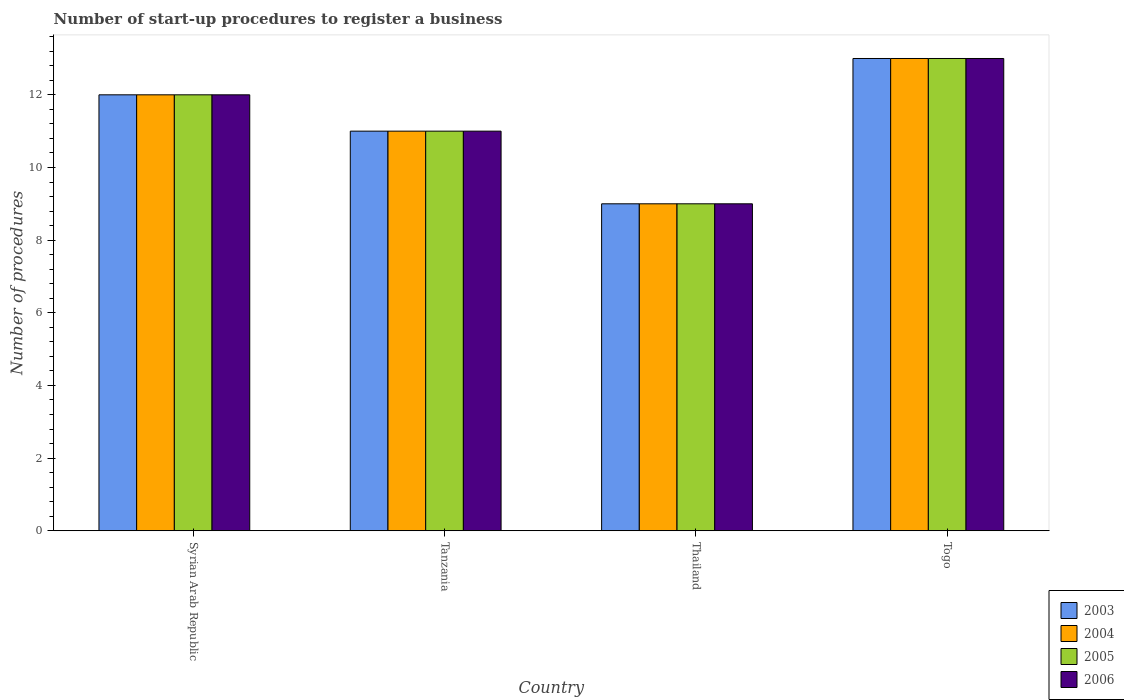How many different coloured bars are there?
Keep it short and to the point. 4. How many groups of bars are there?
Give a very brief answer. 4. Are the number of bars per tick equal to the number of legend labels?
Offer a very short reply. Yes. Are the number of bars on each tick of the X-axis equal?
Provide a short and direct response. Yes. How many bars are there on the 2nd tick from the right?
Give a very brief answer. 4. What is the label of the 3rd group of bars from the left?
Ensure brevity in your answer.  Thailand. Across all countries, what is the maximum number of procedures required to register a business in 2005?
Ensure brevity in your answer.  13. Across all countries, what is the minimum number of procedures required to register a business in 2006?
Offer a terse response. 9. In which country was the number of procedures required to register a business in 2006 maximum?
Give a very brief answer. Togo. In which country was the number of procedures required to register a business in 2006 minimum?
Your answer should be compact. Thailand. What is the average number of procedures required to register a business in 2006 per country?
Your answer should be compact. 11.25. What is the difference between the number of procedures required to register a business of/in 2006 and number of procedures required to register a business of/in 2003 in Tanzania?
Your answer should be compact. 0. In how many countries, is the number of procedures required to register a business in 2006 greater than 12.8?
Offer a very short reply. 1. What is the ratio of the number of procedures required to register a business in 2003 in Syrian Arab Republic to that in Thailand?
Provide a succinct answer. 1.33. Is the number of procedures required to register a business in 2006 in Tanzania less than that in Togo?
Provide a short and direct response. Yes. Is it the case that in every country, the sum of the number of procedures required to register a business in 2006 and number of procedures required to register a business in 2005 is greater than the sum of number of procedures required to register a business in 2004 and number of procedures required to register a business in 2003?
Offer a terse response. No. What does the 2nd bar from the left in Syrian Arab Republic represents?
Give a very brief answer. 2004. What does the 3rd bar from the right in Syrian Arab Republic represents?
Ensure brevity in your answer.  2004. How many bars are there?
Your response must be concise. 16. What is the difference between two consecutive major ticks on the Y-axis?
Offer a terse response. 2. Does the graph contain grids?
Offer a very short reply. No. How are the legend labels stacked?
Provide a succinct answer. Vertical. What is the title of the graph?
Make the answer very short. Number of start-up procedures to register a business. Does "1998" appear as one of the legend labels in the graph?
Ensure brevity in your answer.  No. What is the label or title of the X-axis?
Make the answer very short. Country. What is the label or title of the Y-axis?
Offer a terse response. Number of procedures. What is the Number of procedures in 2004 in Syrian Arab Republic?
Provide a short and direct response. 12. What is the Number of procedures in 2006 in Syrian Arab Republic?
Your answer should be compact. 12. What is the Number of procedures in 2003 in Tanzania?
Provide a short and direct response. 11. What is the Number of procedures of 2004 in Tanzania?
Offer a very short reply. 11. What is the Number of procedures in 2005 in Tanzania?
Offer a terse response. 11. What is the Number of procedures of 2006 in Tanzania?
Give a very brief answer. 11. What is the Number of procedures in 2004 in Thailand?
Offer a terse response. 9. What is the Number of procedures in 2006 in Thailand?
Provide a succinct answer. 9. What is the Number of procedures of 2003 in Togo?
Keep it short and to the point. 13. What is the Number of procedures of 2005 in Togo?
Offer a very short reply. 13. What is the Number of procedures of 2006 in Togo?
Your response must be concise. 13. Across all countries, what is the maximum Number of procedures in 2003?
Give a very brief answer. 13. Across all countries, what is the maximum Number of procedures in 2004?
Provide a short and direct response. 13. Across all countries, what is the maximum Number of procedures of 2005?
Offer a very short reply. 13. Across all countries, what is the minimum Number of procedures in 2006?
Keep it short and to the point. 9. What is the total Number of procedures in 2003 in the graph?
Your response must be concise. 45. What is the total Number of procedures of 2005 in the graph?
Your answer should be compact. 45. What is the total Number of procedures of 2006 in the graph?
Offer a very short reply. 45. What is the difference between the Number of procedures in 2004 in Syrian Arab Republic and that in Tanzania?
Provide a succinct answer. 1. What is the difference between the Number of procedures in 2003 in Syrian Arab Republic and that in Thailand?
Ensure brevity in your answer.  3. What is the difference between the Number of procedures in 2004 in Syrian Arab Republic and that in Thailand?
Keep it short and to the point. 3. What is the difference between the Number of procedures in 2005 in Syrian Arab Republic and that in Thailand?
Your answer should be compact. 3. What is the difference between the Number of procedures in 2003 in Syrian Arab Republic and that in Togo?
Your response must be concise. -1. What is the difference between the Number of procedures of 2004 in Syrian Arab Republic and that in Togo?
Ensure brevity in your answer.  -1. What is the difference between the Number of procedures in 2006 in Syrian Arab Republic and that in Togo?
Offer a very short reply. -1. What is the difference between the Number of procedures of 2003 in Tanzania and that in Thailand?
Give a very brief answer. 2. What is the difference between the Number of procedures of 2004 in Tanzania and that in Thailand?
Provide a succinct answer. 2. What is the difference between the Number of procedures of 2006 in Tanzania and that in Togo?
Offer a very short reply. -2. What is the difference between the Number of procedures in 2003 in Thailand and that in Togo?
Your answer should be very brief. -4. What is the difference between the Number of procedures of 2004 in Thailand and that in Togo?
Offer a terse response. -4. What is the difference between the Number of procedures of 2005 in Thailand and that in Togo?
Keep it short and to the point. -4. What is the difference between the Number of procedures of 2006 in Thailand and that in Togo?
Make the answer very short. -4. What is the difference between the Number of procedures of 2003 in Syrian Arab Republic and the Number of procedures of 2004 in Tanzania?
Ensure brevity in your answer.  1. What is the difference between the Number of procedures of 2003 in Syrian Arab Republic and the Number of procedures of 2005 in Tanzania?
Your answer should be very brief. 1. What is the difference between the Number of procedures in 2004 in Syrian Arab Republic and the Number of procedures in 2005 in Tanzania?
Give a very brief answer. 1. What is the difference between the Number of procedures of 2004 in Syrian Arab Republic and the Number of procedures of 2006 in Tanzania?
Keep it short and to the point. 1. What is the difference between the Number of procedures of 2003 in Syrian Arab Republic and the Number of procedures of 2004 in Thailand?
Offer a terse response. 3. What is the difference between the Number of procedures in 2003 in Syrian Arab Republic and the Number of procedures in 2006 in Togo?
Give a very brief answer. -1. What is the difference between the Number of procedures in 2004 in Syrian Arab Republic and the Number of procedures in 2006 in Togo?
Your response must be concise. -1. What is the difference between the Number of procedures in 2003 in Tanzania and the Number of procedures in 2004 in Thailand?
Ensure brevity in your answer.  2. What is the difference between the Number of procedures in 2003 in Tanzania and the Number of procedures in 2006 in Thailand?
Keep it short and to the point. 2. What is the difference between the Number of procedures in 2004 in Tanzania and the Number of procedures in 2006 in Thailand?
Keep it short and to the point. 2. What is the difference between the Number of procedures of 2005 in Tanzania and the Number of procedures of 2006 in Thailand?
Provide a succinct answer. 2. What is the difference between the Number of procedures in 2003 in Tanzania and the Number of procedures in 2004 in Togo?
Provide a short and direct response. -2. What is the difference between the Number of procedures of 2003 in Tanzania and the Number of procedures of 2005 in Togo?
Ensure brevity in your answer.  -2. What is the difference between the Number of procedures of 2004 in Tanzania and the Number of procedures of 2005 in Togo?
Provide a short and direct response. -2. What is the difference between the Number of procedures in 2004 in Tanzania and the Number of procedures in 2006 in Togo?
Ensure brevity in your answer.  -2. What is the difference between the Number of procedures in 2005 in Tanzania and the Number of procedures in 2006 in Togo?
Offer a very short reply. -2. What is the difference between the Number of procedures of 2003 in Thailand and the Number of procedures of 2004 in Togo?
Make the answer very short. -4. What is the difference between the Number of procedures in 2004 in Thailand and the Number of procedures in 2005 in Togo?
Your answer should be very brief. -4. What is the difference between the Number of procedures in 2004 in Thailand and the Number of procedures in 2006 in Togo?
Offer a very short reply. -4. What is the average Number of procedures of 2003 per country?
Your answer should be compact. 11.25. What is the average Number of procedures in 2004 per country?
Offer a very short reply. 11.25. What is the average Number of procedures in 2005 per country?
Keep it short and to the point. 11.25. What is the average Number of procedures in 2006 per country?
Provide a succinct answer. 11.25. What is the difference between the Number of procedures of 2003 and Number of procedures of 2004 in Syrian Arab Republic?
Make the answer very short. 0. What is the difference between the Number of procedures in 2003 and Number of procedures in 2005 in Syrian Arab Republic?
Provide a succinct answer. 0. What is the difference between the Number of procedures in 2004 and Number of procedures in 2005 in Syrian Arab Republic?
Ensure brevity in your answer.  0. What is the difference between the Number of procedures in 2005 and Number of procedures in 2006 in Syrian Arab Republic?
Give a very brief answer. 0. What is the difference between the Number of procedures of 2003 and Number of procedures of 2004 in Tanzania?
Your answer should be compact. 0. What is the difference between the Number of procedures in 2003 and Number of procedures in 2006 in Tanzania?
Offer a very short reply. 0. What is the difference between the Number of procedures of 2004 and Number of procedures of 2005 in Tanzania?
Your response must be concise. 0. What is the difference between the Number of procedures in 2003 and Number of procedures in 2004 in Thailand?
Give a very brief answer. 0. What is the difference between the Number of procedures of 2003 and Number of procedures of 2005 in Thailand?
Your answer should be very brief. 0. What is the difference between the Number of procedures of 2003 and Number of procedures of 2004 in Togo?
Give a very brief answer. 0. What is the difference between the Number of procedures of 2004 and Number of procedures of 2005 in Togo?
Your answer should be compact. 0. What is the ratio of the Number of procedures of 2003 in Syrian Arab Republic to that in Tanzania?
Keep it short and to the point. 1.09. What is the ratio of the Number of procedures of 2004 in Syrian Arab Republic to that in Tanzania?
Make the answer very short. 1.09. What is the ratio of the Number of procedures in 2005 in Syrian Arab Republic to that in Tanzania?
Ensure brevity in your answer.  1.09. What is the ratio of the Number of procedures in 2005 in Syrian Arab Republic to that in Thailand?
Keep it short and to the point. 1.33. What is the ratio of the Number of procedures in 2003 in Syrian Arab Republic to that in Togo?
Provide a succinct answer. 0.92. What is the ratio of the Number of procedures of 2004 in Syrian Arab Republic to that in Togo?
Your response must be concise. 0.92. What is the ratio of the Number of procedures of 2005 in Syrian Arab Republic to that in Togo?
Make the answer very short. 0.92. What is the ratio of the Number of procedures of 2006 in Syrian Arab Republic to that in Togo?
Keep it short and to the point. 0.92. What is the ratio of the Number of procedures of 2003 in Tanzania to that in Thailand?
Offer a terse response. 1.22. What is the ratio of the Number of procedures of 2004 in Tanzania to that in Thailand?
Keep it short and to the point. 1.22. What is the ratio of the Number of procedures in 2005 in Tanzania to that in Thailand?
Your answer should be compact. 1.22. What is the ratio of the Number of procedures of 2006 in Tanzania to that in Thailand?
Your answer should be compact. 1.22. What is the ratio of the Number of procedures of 2003 in Tanzania to that in Togo?
Make the answer very short. 0.85. What is the ratio of the Number of procedures of 2004 in Tanzania to that in Togo?
Make the answer very short. 0.85. What is the ratio of the Number of procedures of 2005 in Tanzania to that in Togo?
Keep it short and to the point. 0.85. What is the ratio of the Number of procedures of 2006 in Tanzania to that in Togo?
Offer a very short reply. 0.85. What is the ratio of the Number of procedures in 2003 in Thailand to that in Togo?
Your answer should be compact. 0.69. What is the ratio of the Number of procedures of 2004 in Thailand to that in Togo?
Offer a terse response. 0.69. What is the ratio of the Number of procedures in 2005 in Thailand to that in Togo?
Offer a very short reply. 0.69. What is the ratio of the Number of procedures in 2006 in Thailand to that in Togo?
Keep it short and to the point. 0.69. What is the difference between the highest and the second highest Number of procedures of 2003?
Offer a terse response. 1. What is the difference between the highest and the second highest Number of procedures in 2004?
Offer a terse response. 1. What is the difference between the highest and the lowest Number of procedures in 2005?
Provide a short and direct response. 4. What is the difference between the highest and the lowest Number of procedures in 2006?
Offer a terse response. 4. 